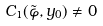<formula> <loc_0><loc_0><loc_500><loc_500>C _ { 1 } ( \tilde { \varphi } , y _ { 0 } ) \neq 0</formula> 